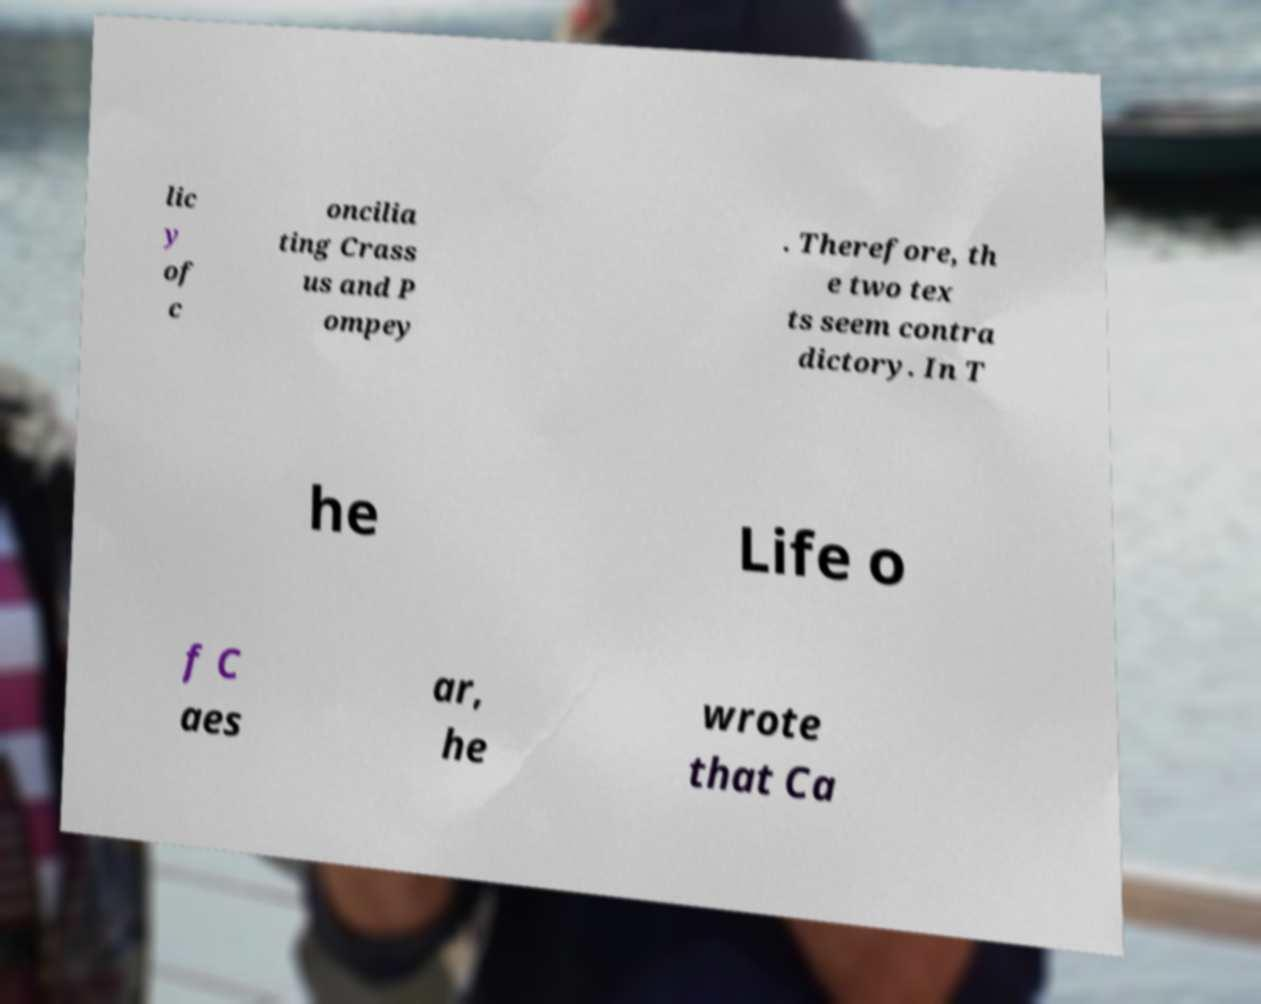Could you extract and type out the text from this image? lic y of c oncilia ting Crass us and P ompey . Therefore, th e two tex ts seem contra dictory. In T he Life o f C aes ar, he wrote that Ca 